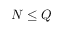<formula> <loc_0><loc_0><loc_500><loc_500>N \leq Q</formula> 